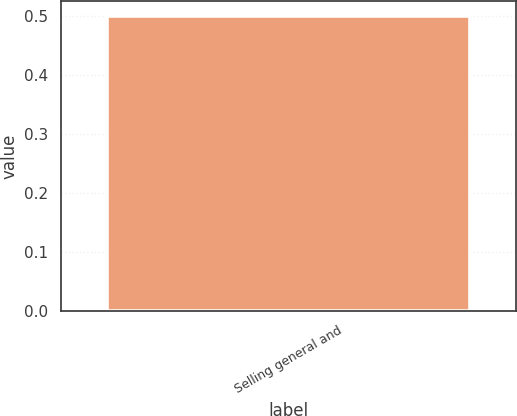<chart> <loc_0><loc_0><loc_500><loc_500><bar_chart><fcel>Selling general and<nl><fcel>0.5<nl></chart> 